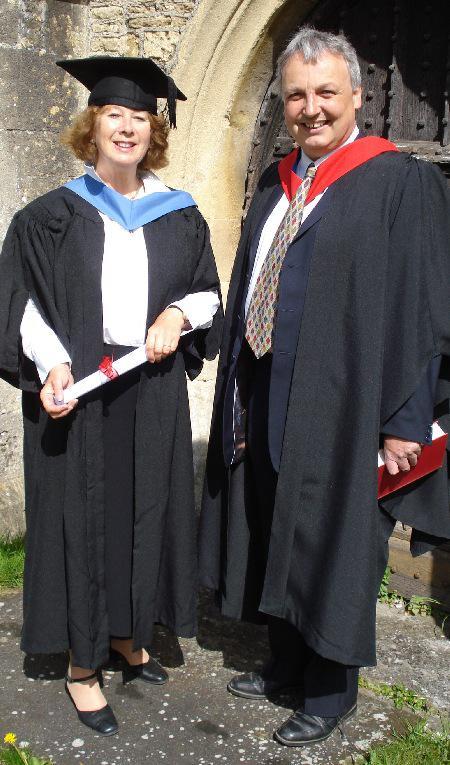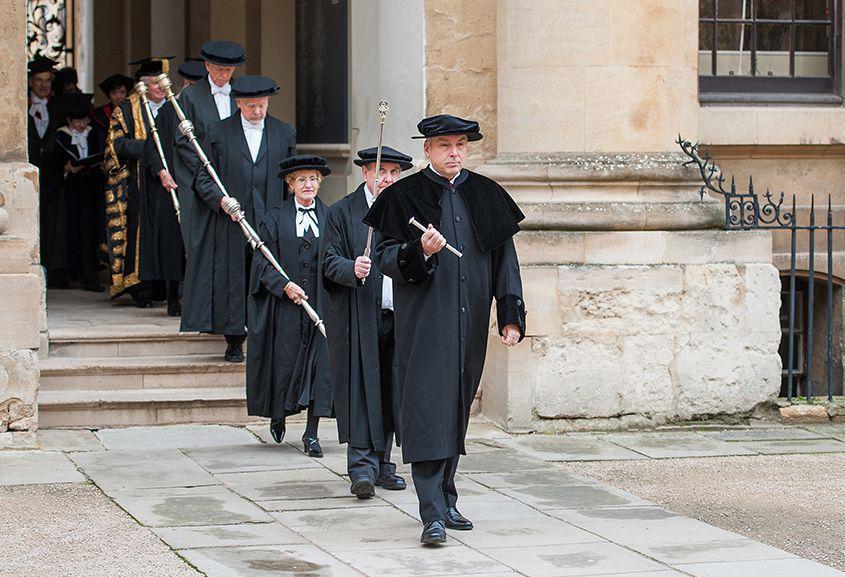The first image is the image on the left, the second image is the image on the right. Considering the images on both sides, is "The left image contains no more than four graduation students." valid? Answer yes or no. Yes. The first image is the image on the left, the second image is the image on the right. Given the left and right images, does the statement "In one image at least two male graduates are wearing white bow ties and at least one female graduate is wearing an untied black string tie and black hosiery." hold true? Answer yes or no. No. 